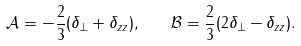Convert formula to latex. <formula><loc_0><loc_0><loc_500><loc_500>\mathcal { A } = - \frac { 2 } { 3 } ( \delta _ { \perp } + \delta _ { z z } ) , \quad \mathcal { B } = \frac { 2 } { 3 } ( 2 \delta _ { \perp } - \delta _ { z z } ) .</formula> 